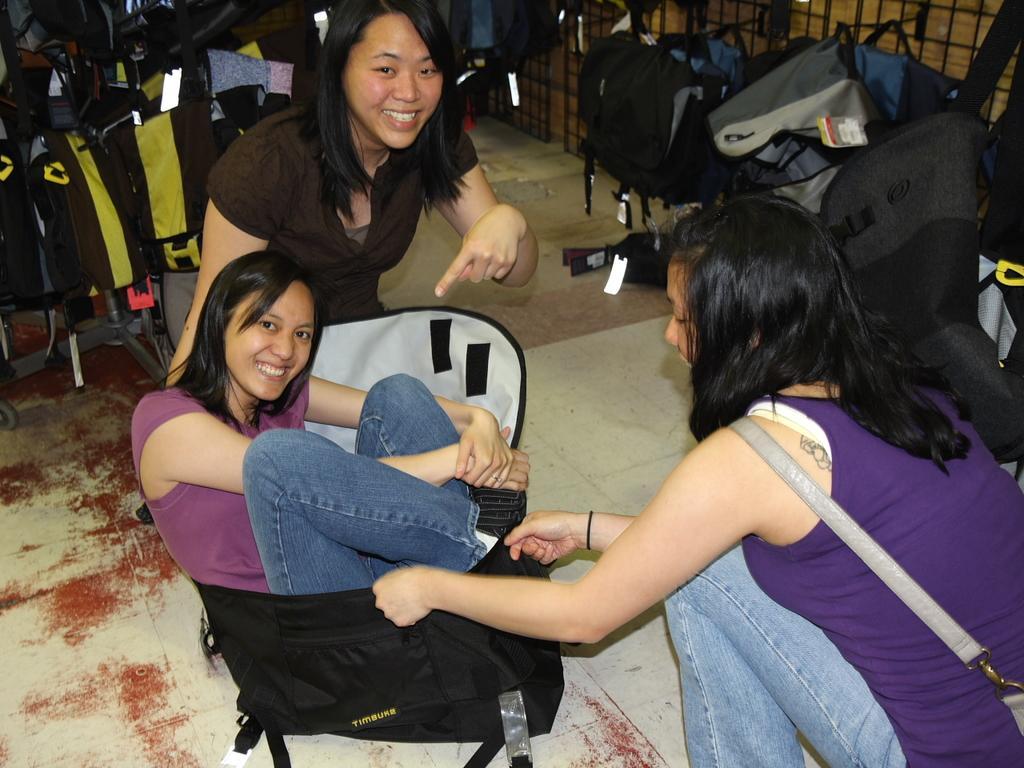Describe this image in one or two sentences. In this picture we can see three women, they are smiling, and a woman is seated in the bag, around them we can find few bags and metal rods. 